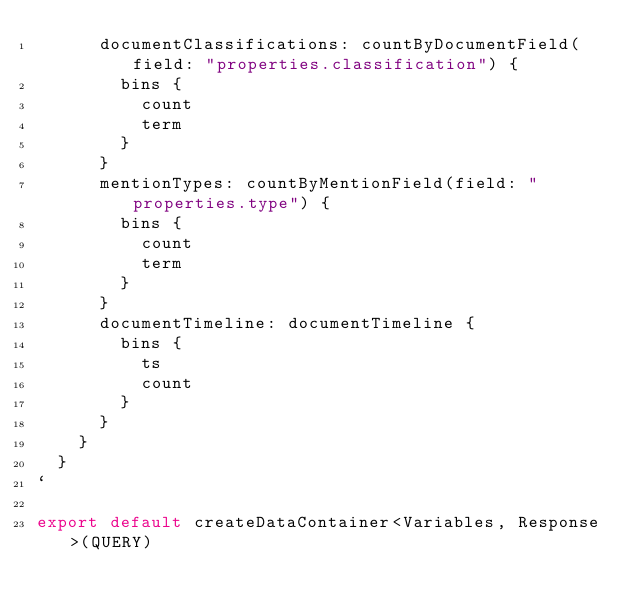<code> <loc_0><loc_0><loc_500><loc_500><_TypeScript_>      documentClassifications: countByDocumentField(field: "properties.classification") {
        bins {
          count
          term
        }
      }
      mentionTypes: countByMentionField(field: "properties.type") {
        bins {
          count
          term
        }
      }
      documentTimeline: documentTimeline {
        bins {
          ts
          count
        }
      }
    }
  }
`

export default createDataContainer<Variables, Response>(QUERY)
</code> 